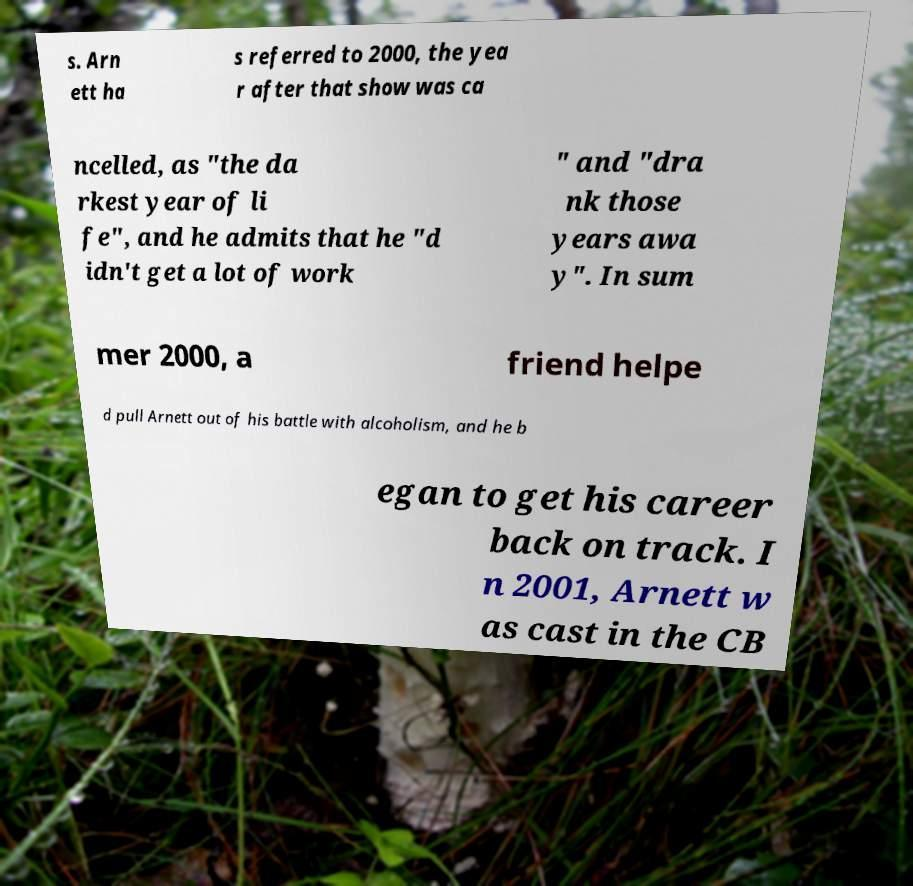Could you assist in decoding the text presented in this image and type it out clearly? s. Arn ett ha s referred to 2000, the yea r after that show was ca ncelled, as "the da rkest year of li fe", and he admits that he "d idn't get a lot of work " and "dra nk those years awa y". In sum mer 2000, a friend helpe d pull Arnett out of his battle with alcoholism, and he b egan to get his career back on track. I n 2001, Arnett w as cast in the CB 